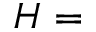<formula> <loc_0><loc_0><loc_500><loc_500>H =</formula> 